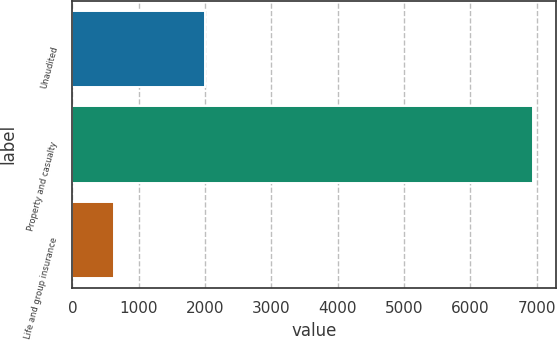Convert chart to OTSL. <chart><loc_0><loc_0><loc_500><loc_500><bar_chart><fcel>Unaudited<fcel>Property and casualty<fcel>Life and group insurance<nl><fcel>2005<fcel>6940<fcel>627<nl></chart> 